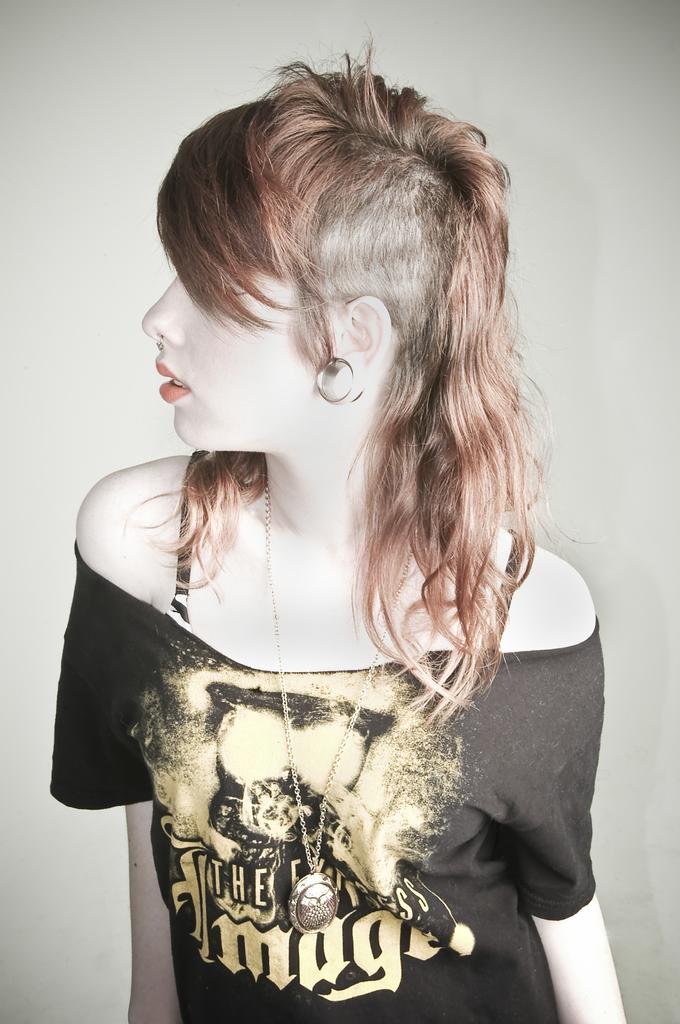How would you summarize this image in a sentence or two? A beautiful woman is there, she wore black color t-shirt and also a chain. 